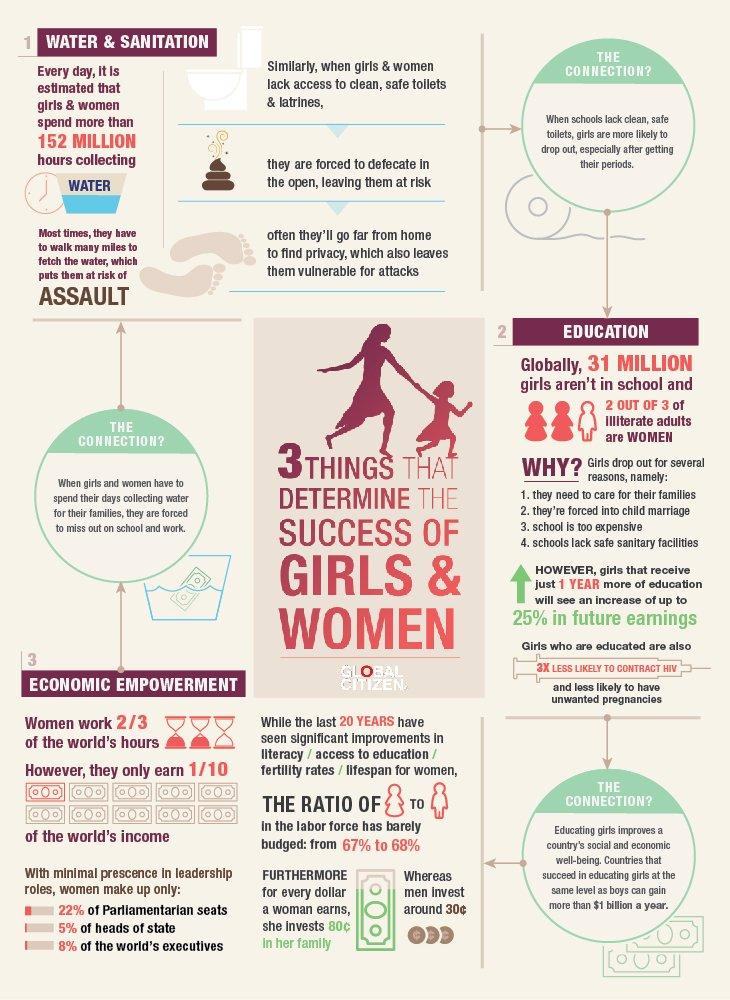Give some essential details in this illustration. The average man invests 30 cents for every dollar earned in his family. Women earn only a fraction of the world's total income, a mere 10% of the global income. According to recent estimates, 152 million hours are spent by girls and women each year collecting water, a vital resource that is critical for survival. A year more of education can increase a girl's future earnings by 25%. 